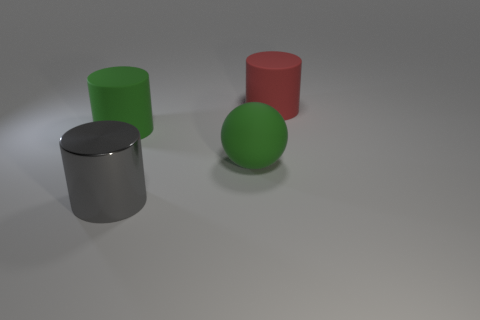Is the green thing that is to the left of the large shiny cylinder made of the same material as the large gray thing?
Your answer should be compact. No. Is the shape of the big gray object the same as the big red matte thing?
Your answer should be very brief. Yes. What shape is the large green rubber object that is on the left side of the rubber object that is in front of the large green rubber object that is behind the green matte sphere?
Ensure brevity in your answer.  Cylinder. Do the big green thing that is left of the metal cylinder and the green object on the right side of the big gray cylinder have the same shape?
Your answer should be very brief. No. Is there a block that has the same material as the red cylinder?
Your response must be concise. No. What is the color of the large cylinder in front of the rubber cylinder that is to the left of the red matte thing that is behind the large gray metal cylinder?
Offer a very short reply. Gray. Is the material of the big cylinder that is behind the green cylinder the same as the green thing on the left side of the large rubber sphere?
Give a very brief answer. Yes. The big green matte object that is left of the big shiny thing has what shape?
Make the answer very short. Cylinder. What number of things are either red cylinders or big objects in front of the big green matte ball?
Give a very brief answer. 2. Does the large sphere have the same material as the big gray cylinder?
Your answer should be compact. No. 